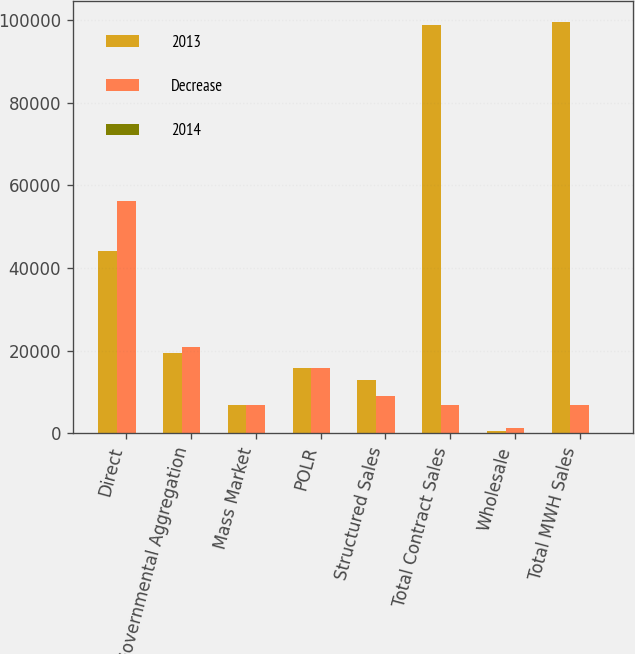Convert chart. <chart><loc_0><loc_0><loc_500><loc_500><stacked_bar_chart><ecel><fcel>Direct<fcel>Governmental Aggregation<fcel>Mass Market<fcel>POLR<fcel>Structured Sales<fcel>Total Contract Sales<fcel>Wholesale<fcel>Total MWH Sales<nl><fcel>2013<fcel>44012<fcel>19569<fcel>6773<fcel>15708<fcel>12814<fcel>98876<fcel>680<fcel>99556<nl><fcel>Decrease<fcel>56145<fcel>20859<fcel>6761<fcel>15758<fcel>9047<fcel>6767<fcel>1250<fcel>6767<nl><fcel>2014<fcel>21.6<fcel>6.2<fcel>0.2<fcel>0.3<fcel>41.6<fcel>8.9<fcel>45.6<fcel>9.3<nl></chart> 